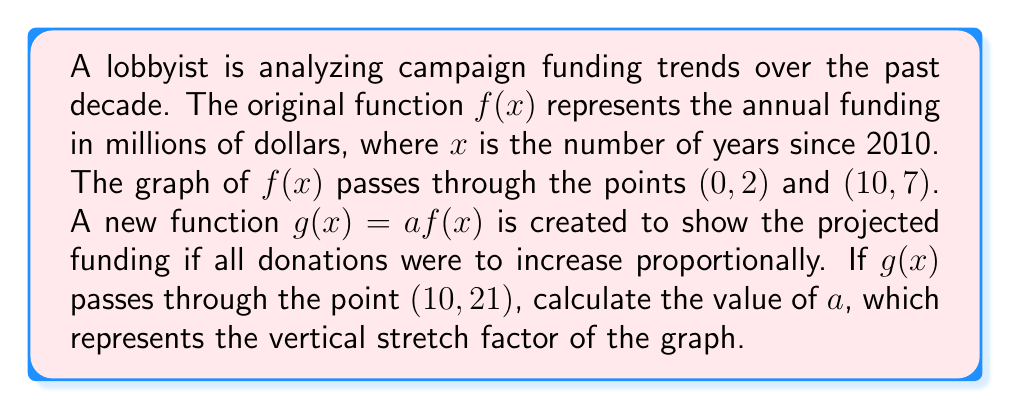Can you solve this math problem? To solve this problem, we'll follow these steps:

1) First, we need to understand what $a$ represents in the function $g(x) = af(x)$. The value of $a$ is the vertical stretch factor, which multiplies all y-values of the original function $f(x)$.

2) We know two points on the original function $f(x)$:
   (0, 2) and (10, 7)

3) We also know one point on the new function $g(x)$:
   (10, 21)

4) Since $g(x) = af(x)$, we can write:
   $g(10) = af(10)$

5) We know that $f(10) = 7$ (from the original function) and $g(10) = 21$ (given in the question). Let's substitute these values:

   $21 = a(7)$

6) Now we can solve for $a$:
   
   $a = \frac{21}{7} = 3$

Therefore, the vertical stretch factor is 3, meaning all y-values of the original function are tripled in the new function.
Answer: $a = 3$ 